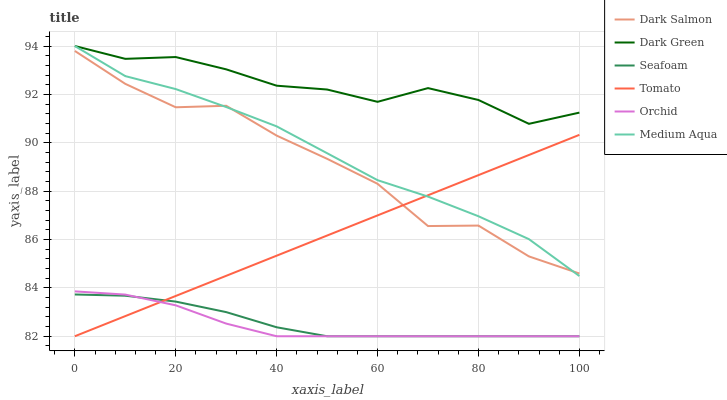Does Orchid have the minimum area under the curve?
Answer yes or no. Yes. Does Dark Green have the maximum area under the curve?
Answer yes or no. Yes. Does Seafoam have the minimum area under the curve?
Answer yes or no. No. Does Seafoam have the maximum area under the curve?
Answer yes or no. No. Is Tomato the smoothest?
Answer yes or no. Yes. Is Dark Salmon the roughest?
Answer yes or no. Yes. Is Seafoam the smoothest?
Answer yes or no. No. Is Seafoam the roughest?
Answer yes or no. No. Does Tomato have the lowest value?
Answer yes or no. Yes. Does Dark Salmon have the lowest value?
Answer yes or no. No. Does Dark Green have the highest value?
Answer yes or no. Yes. Does Dark Salmon have the highest value?
Answer yes or no. No. Is Tomato less than Dark Green?
Answer yes or no. Yes. Is Dark Green greater than Tomato?
Answer yes or no. Yes. Does Medium Aqua intersect Tomato?
Answer yes or no. Yes. Is Medium Aqua less than Tomato?
Answer yes or no. No. Is Medium Aqua greater than Tomato?
Answer yes or no. No. Does Tomato intersect Dark Green?
Answer yes or no. No. 